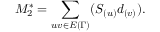Convert formula to latex. <formula><loc_0><loc_0><loc_500><loc_500>M _ { 2 } ^ { * } = \sum _ { u v \in E { ( \Gamma ) } } ( S _ { ( u ) } d _ { ( v ) } ) .</formula> 